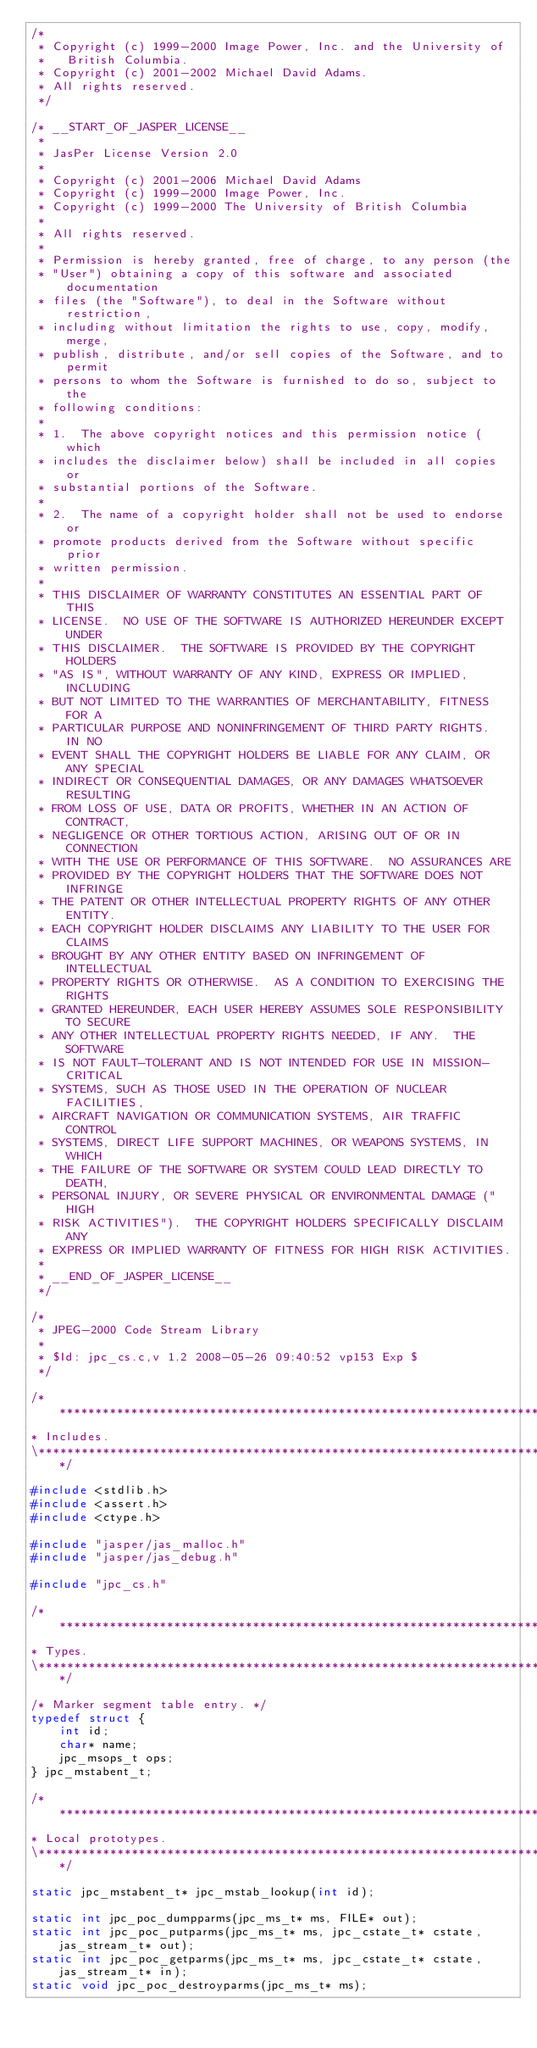Convert code to text. <code><loc_0><loc_0><loc_500><loc_500><_C_>/*
 * Copyright (c) 1999-2000 Image Power, Inc. and the University of
 *   British Columbia.
 * Copyright (c) 2001-2002 Michael David Adams.
 * All rights reserved.
 */

/* __START_OF_JASPER_LICENSE__
 *
 * JasPer License Version 2.0
 *
 * Copyright (c) 2001-2006 Michael David Adams
 * Copyright (c) 1999-2000 Image Power, Inc.
 * Copyright (c) 1999-2000 The University of British Columbia
 *
 * All rights reserved.
 *
 * Permission is hereby granted, free of charge, to any person (the
 * "User") obtaining a copy of this software and associated documentation
 * files (the "Software"), to deal in the Software without restriction,
 * including without limitation the rights to use, copy, modify, merge,
 * publish, distribute, and/or sell copies of the Software, and to permit
 * persons to whom the Software is furnished to do so, subject to the
 * following conditions:
 *
 * 1.  The above copyright notices and this permission notice (which
 * includes the disclaimer below) shall be included in all copies or
 * substantial portions of the Software.
 *
 * 2.  The name of a copyright holder shall not be used to endorse or
 * promote products derived from the Software without specific prior
 * written permission.
 *
 * THIS DISCLAIMER OF WARRANTY CONSTITUTES AN ESSENTIAL PART OF THIS
 * LICENSE.  NO USE OF THE SOFTWARE IS AUTHORIZED HEREUNDER EXCEPT UNDER
 * THIS DISCLAIMER.  THE SOFTWARE IS PROVIDED BY THE COPYRIGHT HOLDERS
 * "AS IS", WITHOUT WARRANTY OF ANY KIND, EXPRESS OR IMPLIED, INCLUDING
 * BUT NOT LIMITED TO THE WARRANTIES OF MERCHANTABILITY, FITNESS FOR A
 * PARTICULAR PURPOSE AND NONINFRINGEMENT OF THIRD PARTY RIGHTS.  IN NO
 * EVENT SHALL THE COPYRIGHT HOLDERS BE LIABLE FOR ANY CLAIM, OR ANY SPECIAL
 * INDIRECT OR CONSEQUENTIAL DAMAGES, OR ANY DAMAGES WHATSOEVER RESULTING
 * FROM LOSS OF USE, DATA OR PROFITS, WHETHER IN AN ACTION OF CONTRACT,
 * NEGLIGENCE OR OTHER TORTIOUS ACTION, ARISING OUT OF OR IN CONNECTION
 * WITH THE USE OR PERFORMANCE OF THIS SOFTWARE.  NO ASSURANCES ARE
 * PROVIDED BY THE COPYRIGHT HOLDERS THAT THE SOFTWARE DOES NOT INFRINGE
 * THE PATENT OR OTHER INTELLECTUAL PROPERTY RIGHTS OF ANY OTHER ENTITY.
 * EACH COPYRIGHT HOLDER DISCLAIMS ANY LIABILITY TO THE USER FOR CLAIMS
 * BROUGHT BY ANY OTHER ENTITY BASED ON INFRINGEMENT OF INTELLECTUAL
 * PROPERTY RIGHTS OR OTHERWISE.  AS A CONDITION TO EXERCISING THE RIGHTS
 * GRANTED HEREUNDER, EACH USER HEREBY ASSUMES SOLE RESPONSIBILITY TO SECURE
 * ANY OTHER INTELLECTUAL PROPERTY RIGHTS NEEDED, IF ANY.  THE SOFTWARE
 * IS NOT FAULT-TOLERANT AND IS NOT INTENDED FOR USE IN MISSION-CRITICAL
 * SYSTEMS, SUCH AS THOSE USED IN THE OPERATION OF NUCLEAR FACILITIES,
 * AIRCRAFT NAVIGATION OR COMMUNICATION SYSTEMS, AIR TRAFFIC CONTROL
 * SYSTEMS, DIRECT LIFE SUPPORT MACHINES, OR WEAPONS SYSTEMS, IN WHICH
 * THE FAILURE OF THE SOFTWARE OR SYSTEM COULD LEAD DIRECTLY TO DEATH,
 * PERSONAL INJURY, OR SEVERE PHYSICAL OR ENVIRONMENTAL DAMAGE ("HIGH
 * RISK ACTIVITIES").  THE COPYRIGHT HOLDERS SPECIFICALLY DISCLAIM ANY
 * EXPRESS OR IMPLIED WARRANTY OF FITNESS FOR HIGH RISK ACTIVITIES.
 *
 * __END_OF_JASPER_LICENSE__
 */

/*
 * JPEG-2000 Code Stream Library
 *
 * $Id: jpc_cs.c,v 1.2 2008-05-26 09:40:52 vp153 Exp $
 */

/******************************************************************************\
* Includes.
\******************************************************************************/

#include <stdlib.h>
#include <assert.h>
#include <ctype.h>

#include "jasper/jas_malloc.h"
#include "jasper/jas_debug.h"

#include "jpc_cs.h"

/******************************************************************************\
* Types.
\******************************************************************************/

/* Marker segment table entry. */
typedef struct {
    int id;
    char* name;
    jpc_msops_t ops;
} jpc_mstabent_t;

/******************************************************************************\
* Local prototypes.
\******************************************************************************/

static jpc_mstabent_t* jpc_mstab_lookup(int id);

static int jpc_poc_dumpparms(jpc_ms_t* ms, FILE* out);
static int jpc_poc_putparms(jpc_ms_t* ms, jpc_cstate_t* cstate, jas_stream_t* out);
static int jpc_poc_getparms(jpc_ms_t* ms, jpc_cstate_t* cstate, jas_stream_t* in);
static void jpc_poc_destroyparms(jpc_ms_t* ms);
</code> 